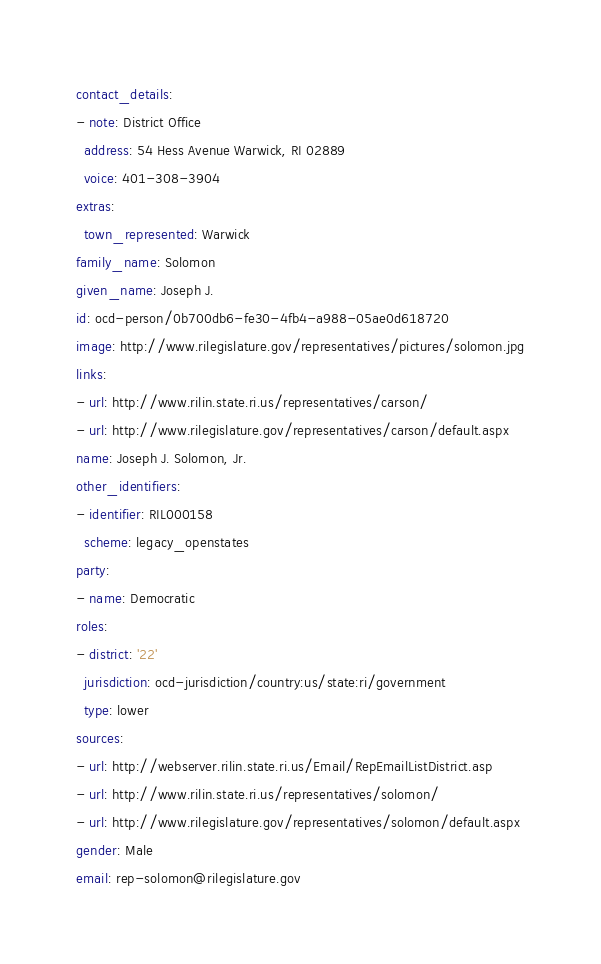Convert code to text. <code><loc_0><loc_0><loc_500><loc_500><_YAML_>contact_details:
- note: District Office
  address: 54 Hess Avenue Warwick, RI 02889
  voice: 401-308-3904
extras:
  town_represented: Warwick
family_name: Solomon
given_name: Joseph J.
id: ocd-person/0b700db6-fe30-4fb4-a988-05ae0d618720
image: http://www.rilegislature.gov/representatives/pictures/solomon.jpg
links:
- url: http://www.rilin.state.ri.us/representatives/carson/
- url: http://www.rilegislature.gov/representatives/carson/default.aspx
name: Joseph J. Solomon, Jr.
other_identifiers:
- identifier: RIL000158
  scheme: legacy_openstates
party:
- name: Democratic
roles:
- district: '22'
  jurisdiction: ocd-jurisdiction/country:us/state:ri/government
  type: lower
sources:
- url: http://webserver.rilin.state.ri.us/Email/RepEmailListDistrict.asp
- url: http://www.rilin.state.ri.us/representatives/solomon/
- url: http://www.rilegislature.gov/representatives/solomon/default.aspx
gender: Male
email: rep-solomon@rilegislature.gov
</code> 